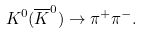Convert formula to latex. <formula><loc_0><loc_0><loc_500><loc_500>K ^ { 0 } ( \overline { K } ^ { 0 } ) \rightarrow \pi ^ { + } \pi ^ { - } .</formula> 